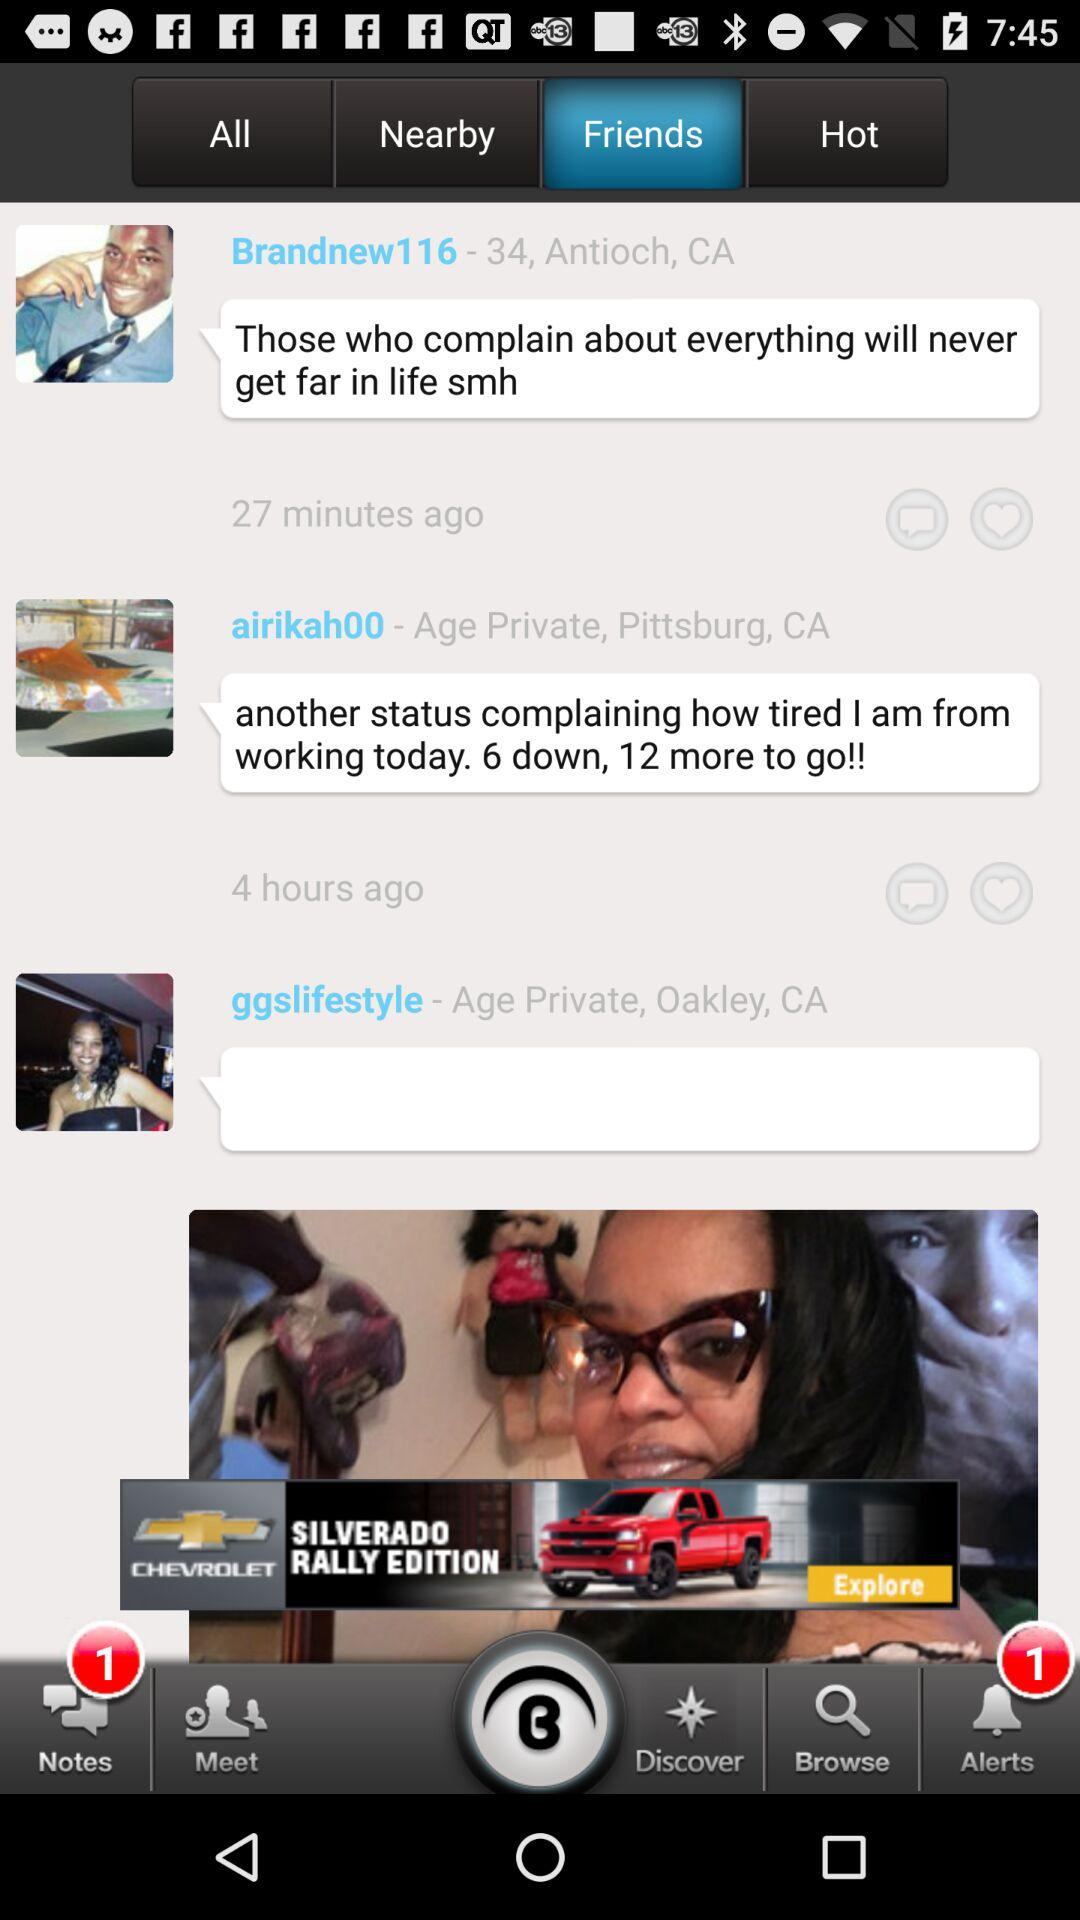What is the age of "Brandnew116"? "Brandnew116" is 34 years. 